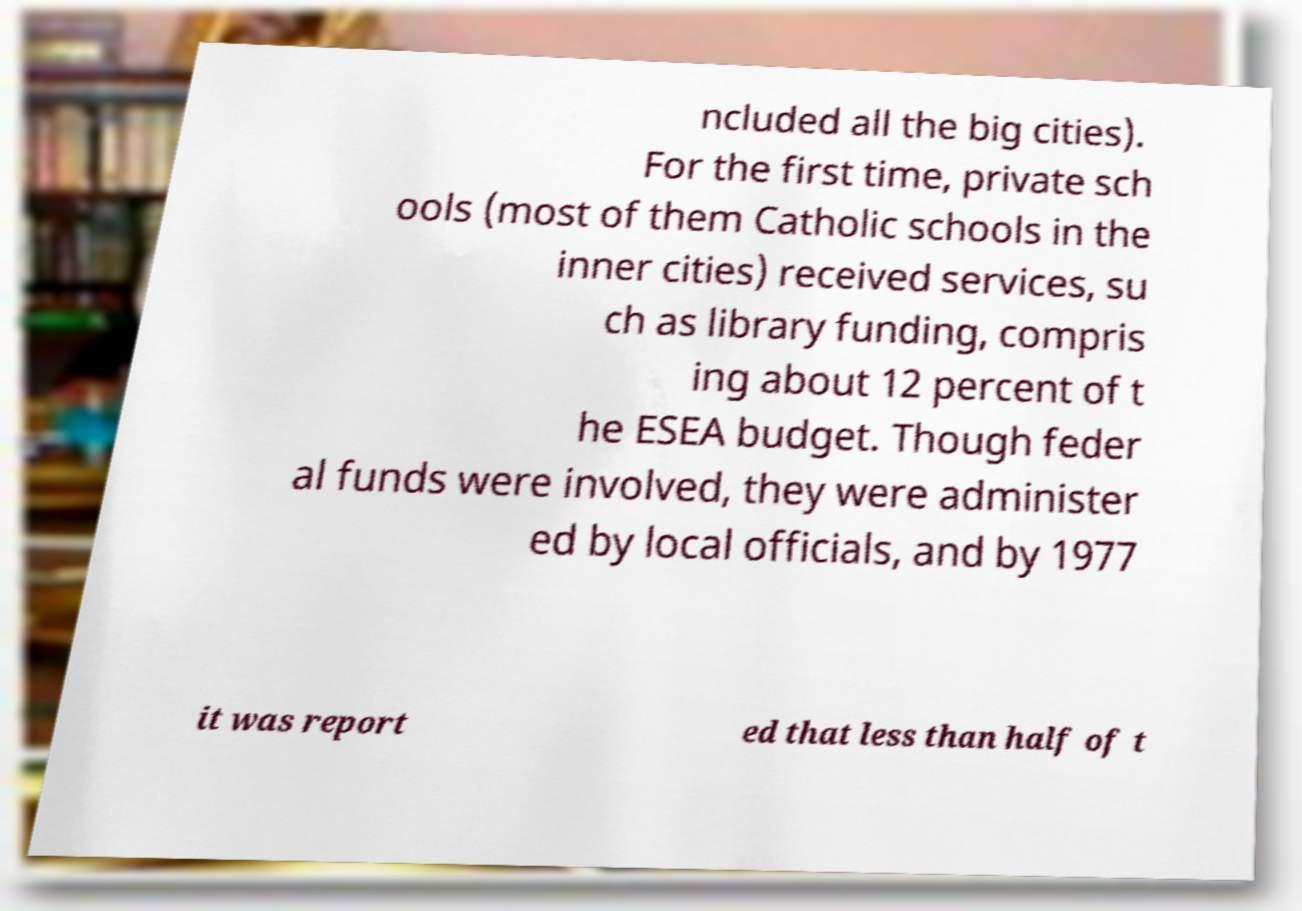Can you read and provide the text displayed in the image?This photo seems to have some interesting text. Can you extract and type it out for me? ncluded all the big cities). For the first time, private sch ools (most of them Catholic schools in the inner cities) received services, su ch as library funding, compris ing about 12 percent of t he ESEA budget. Though feder al funds were involved, they were administer ed by local officials, and by 1977 it was report ed that less than half of t 